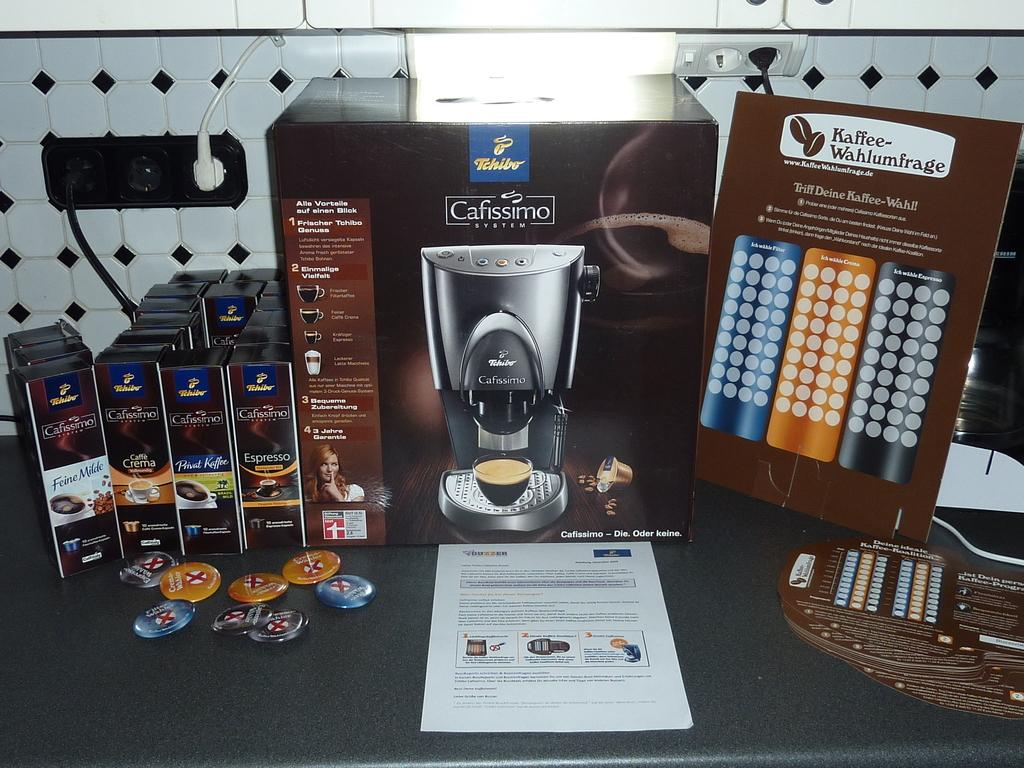<image>
Provide a brief description of the given image. Cafissimo System machine for making coffee and list of products on that machine. 